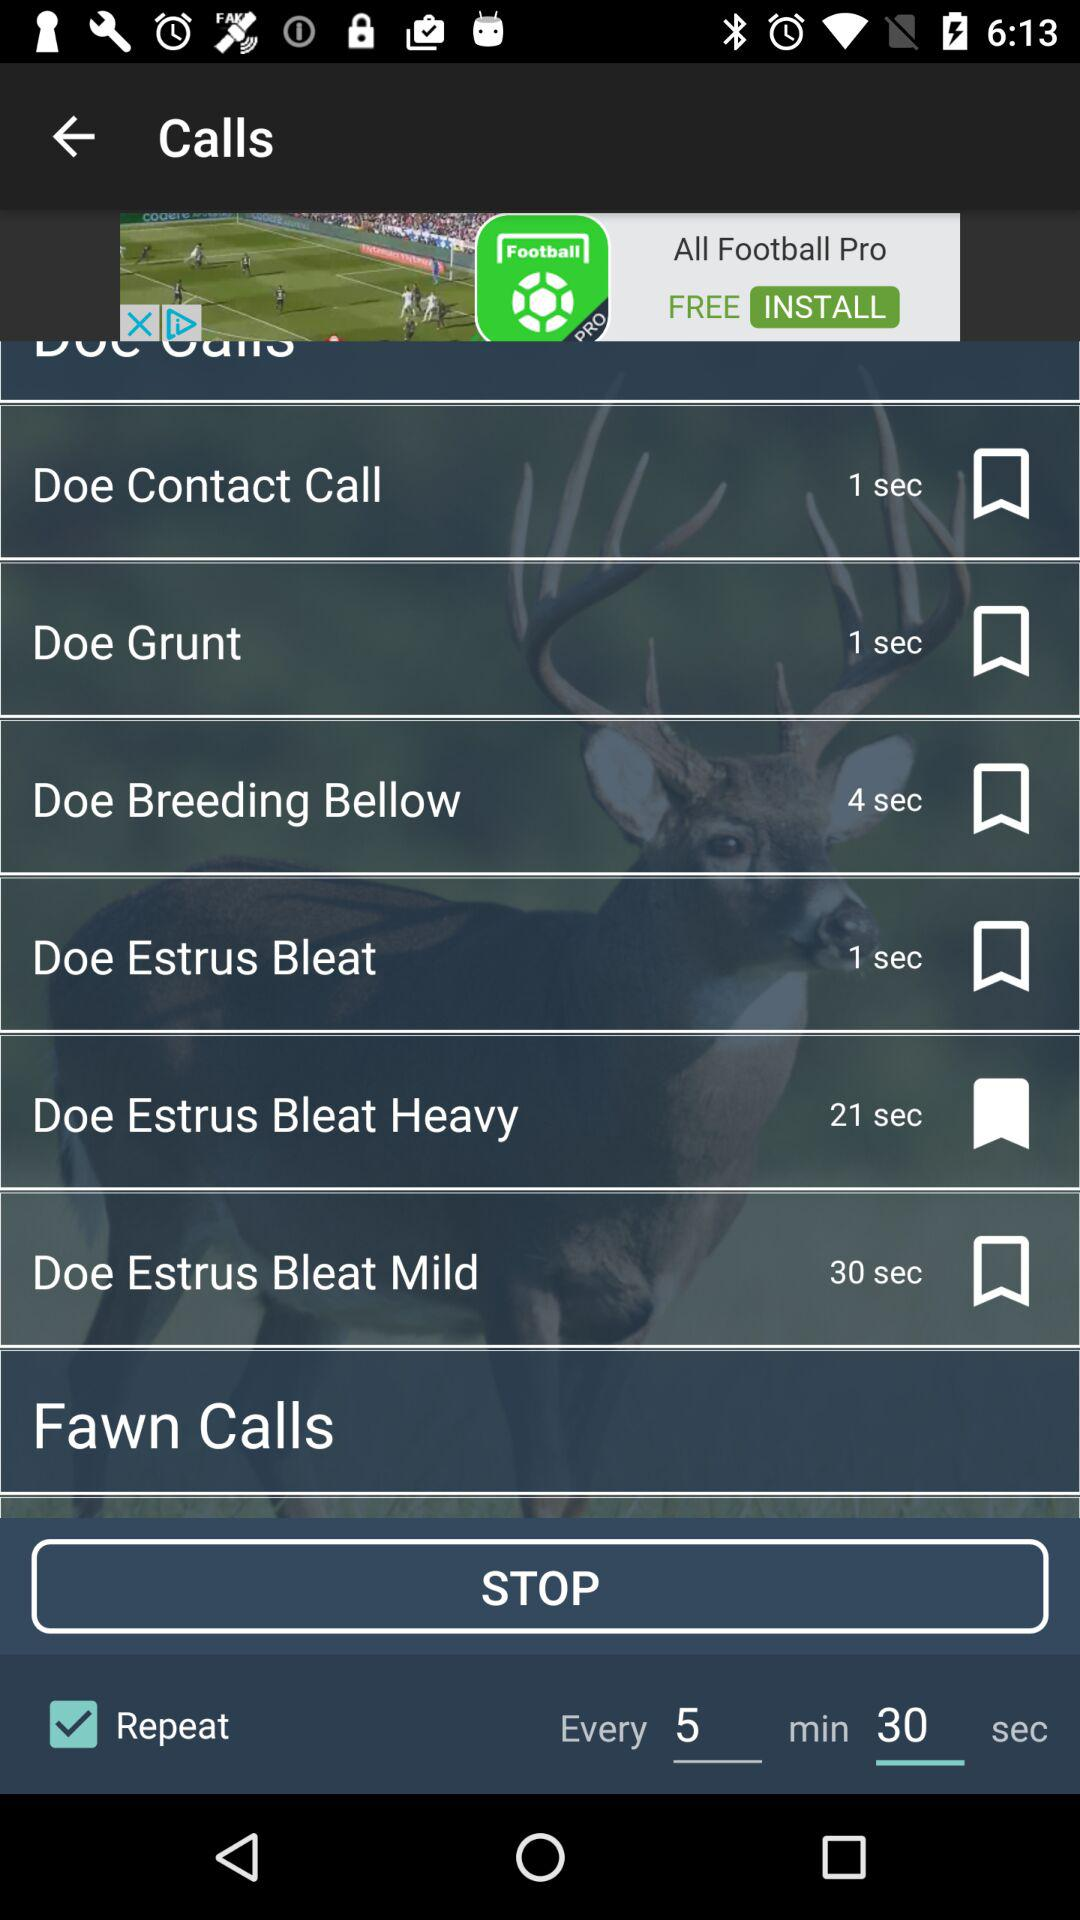What is the time duration of the Doe Breeding Bellow? The time duration of the Doe Breeding Bellow is 4 seconds. 